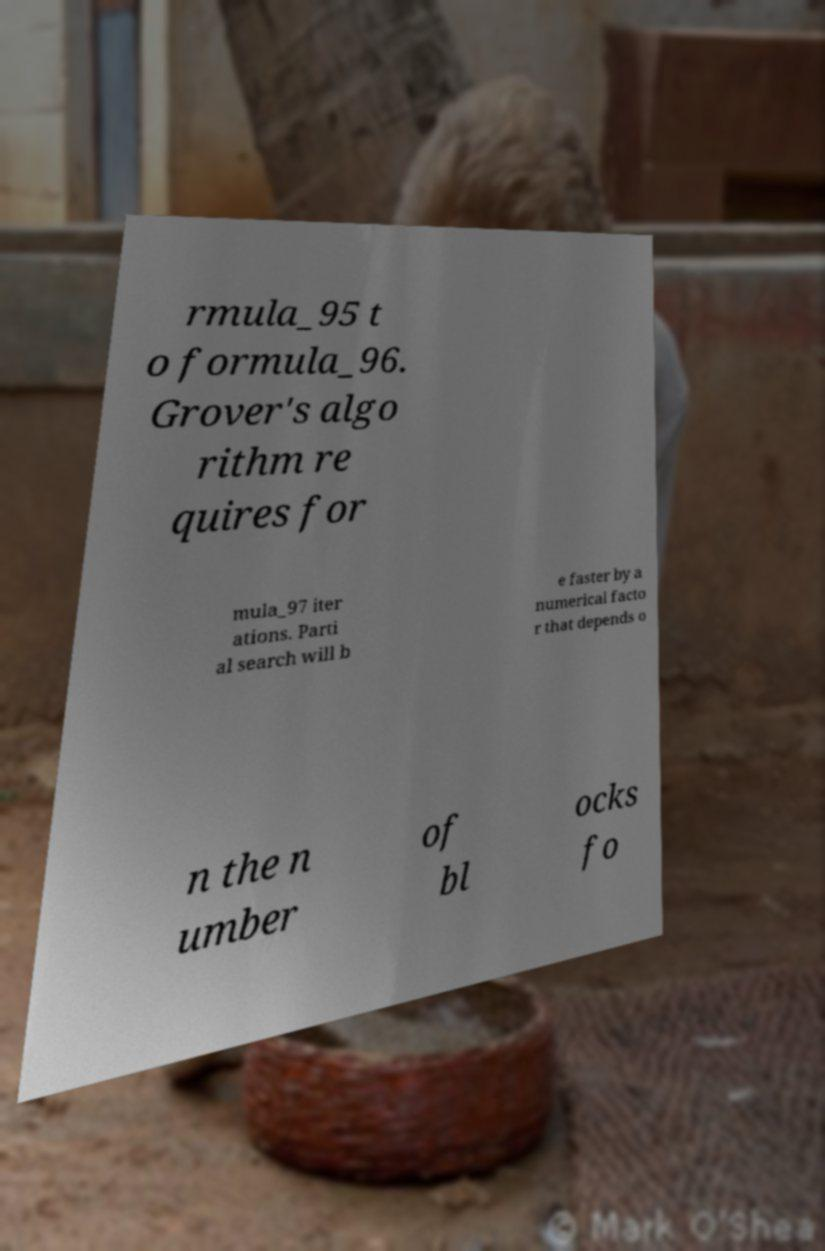There's text embedded in this image that I need extracted. Can you transcribe it verbatim? rmula_95 t o formula_96. Grover's algo rithm re quires for mula_97 iter ations. Parti al search will b e faster by a numerical facto r that depends o n the n umber of bl ocks fo 